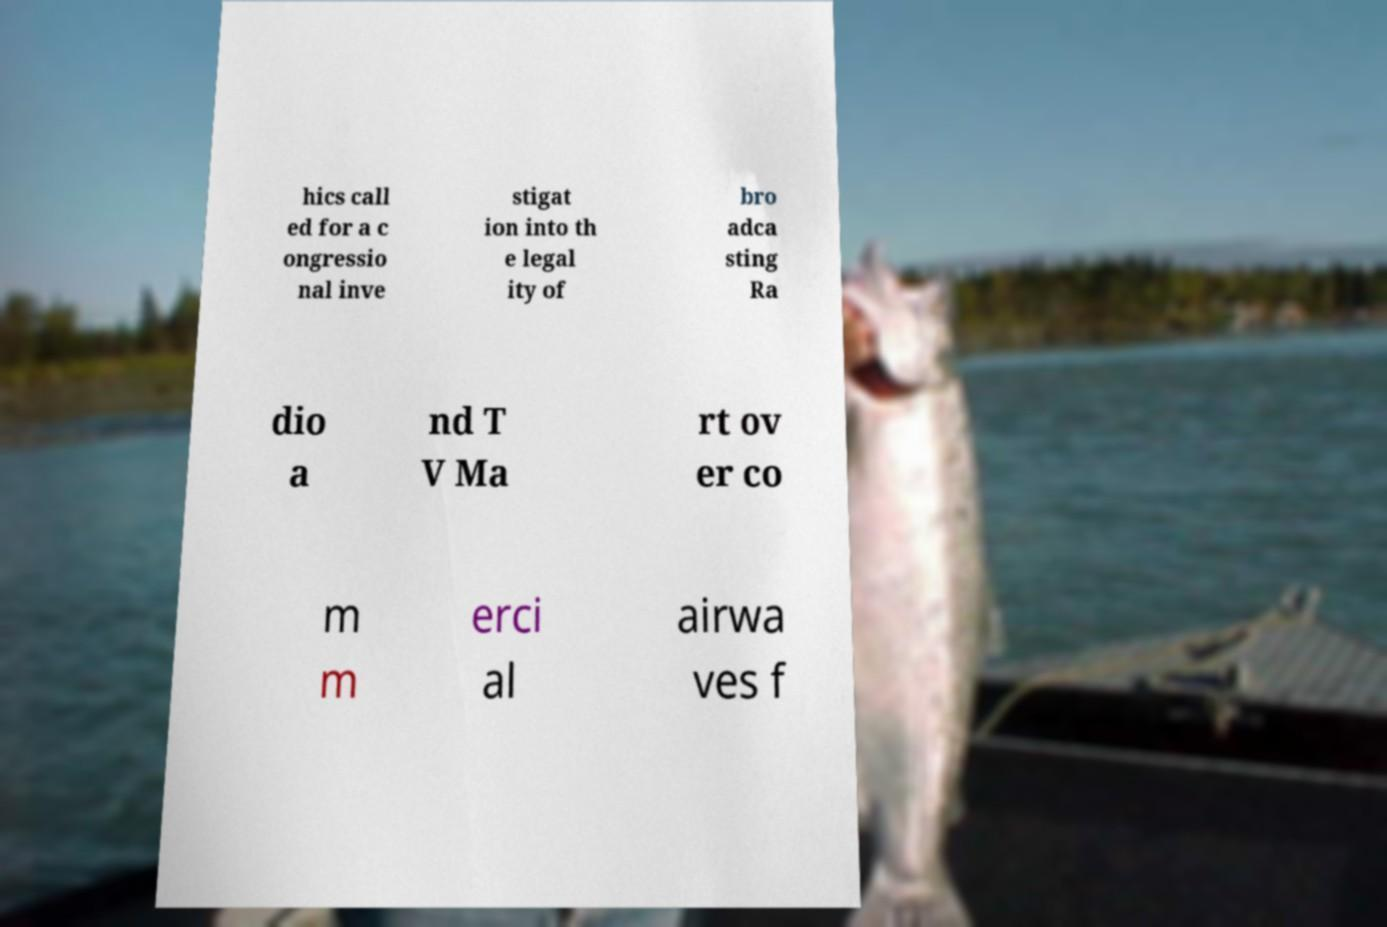There's text embedded in this image that I need extracted. Can you transcribe it verbatim? hics call ed for a c ongressio nal inve stigat ion into th e legal ity of bro adca sting Ra dio a nd T V Ma rt ov er co m m erci al airwa ves f 